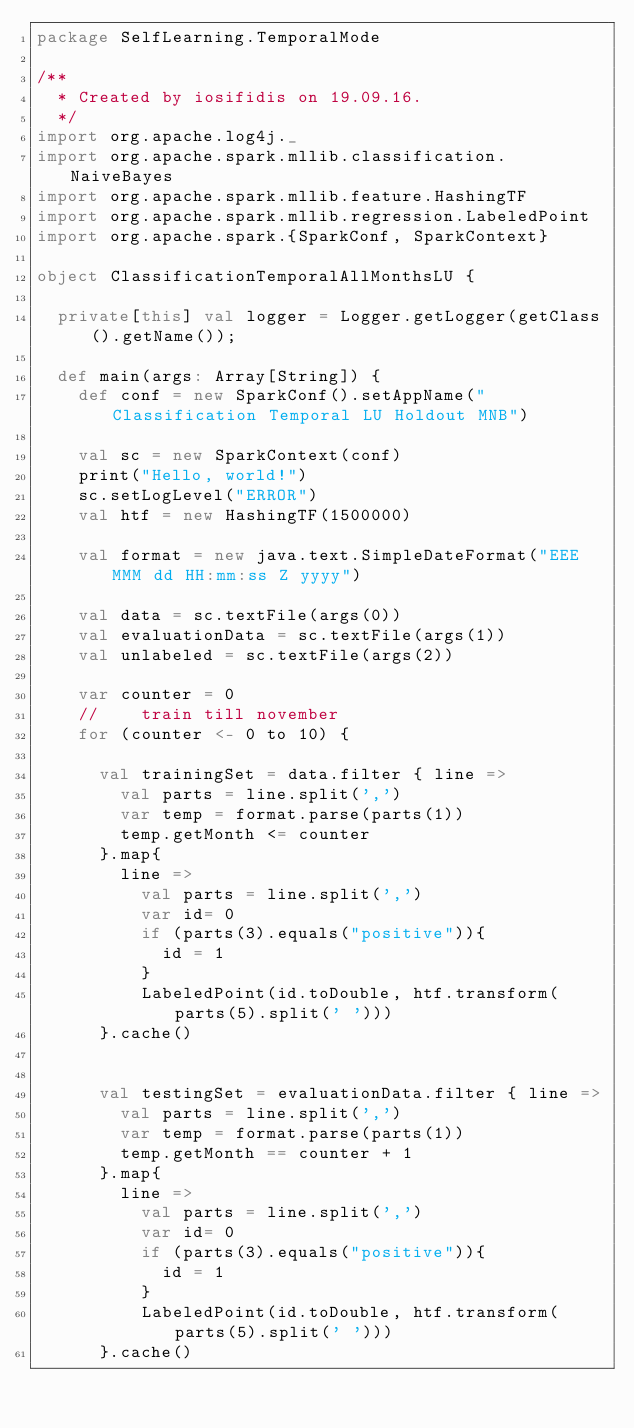<code> <loc_0><loc_0><loc_500><loc_500><_Scala_>package SelfLearning.TemporalMode

/**
  * Created by iosifidis on 19.09.16.
  */
import org.apache.log4j._
import org.apache.spark.mllib.classification.NaiveBayes
import org.apache.spark.mllib.feature.HashingTF
import org.apache.spark.mllib.regression.LabeledPoint
import org.apache.spark.{SparkConf, SparkContext}

object ClassificationTemporalAllMonthsLU {

  private[this] val logger = Logger.getLogger(getClass().getName());

  def main(args: Array[String]) {
    def conf = new SparkConf().setAppName("Classification Temporal LU Holdout MNB")

    val sc = new SparkContext(conf)
    print("Hello, world!")
    sc.setLogLevel("ERROR")
    val htf = new HashingTF(1500000)

    val format = new java.text.SimpleDateFormat("EEE MMM dd HH:mm:ss Z yyyy")

    val data = sc.textFile(args(0))
    val evaluationData = sc.textFile(args(1))
    val unlabeled = sc.textFile(args(2))

    var counter = 0
    //    train till november
    for (counter <- 0 to 10) {

      val trainingSet = data.filter { line =>
        val parts = line.split(',')
        var temp = format.parse(parts(1))
        temp.getMonth <= counter
      }.map{
        line =>
          val parts = line.split(',')
          var id= 0
          if (parts(3).equals("positive")){
            id = 1
          }
          LabeledPoint(id.toDouble, htf.transform(parts(5).split(' ')))
      }.cache()


      val testingSet = evaluationData.filter { line =>
        val parts = line.split(',')
        var temp = format.parse(parts(1))
        temp.getMonth == counter + 1
      }.map{
        line =>
          val parts = line.split(',')
          var id= 0
          if (parts(3).equals("positive")){
            id = 1
          }
          LabeledPoint(id.toDouble, htf.transform(parts(5).split(' ')))
      }.cache()
</code> 